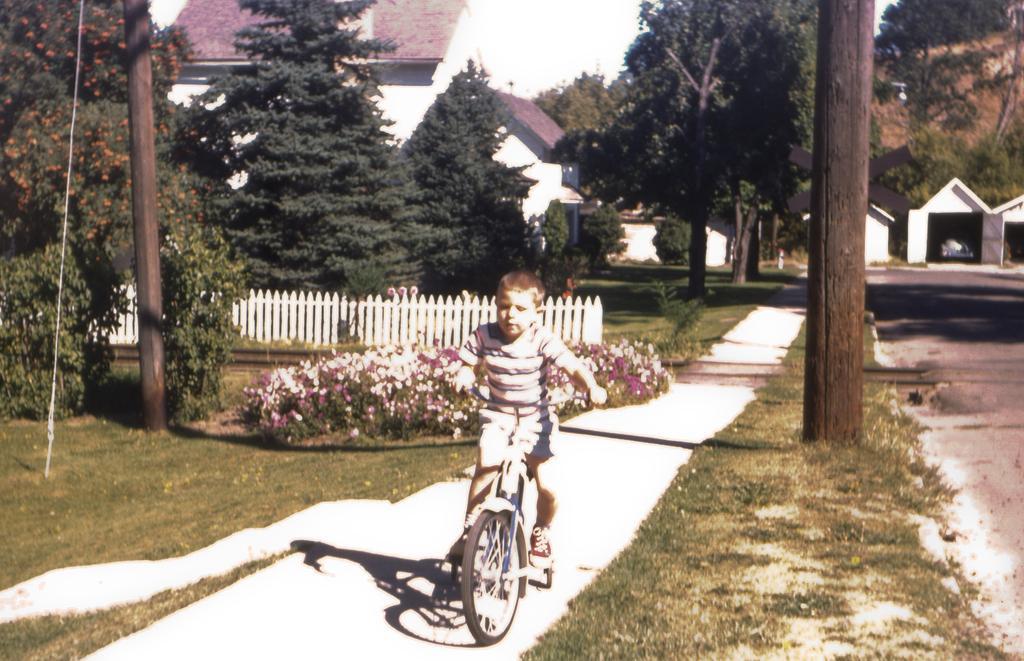In one or two sentences, can you explain what this image depicts? On the background we can see house, trees. We can see a boy riding bicycle hire. This is a grass. We can see flower plants. We can see a fence in white colour. 